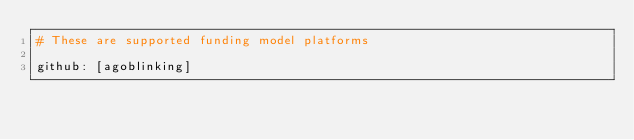<code> <loc_0><loc_0><loc_500><loc_500><_YAML_># These are supported funding model platforms

github: [agoblinking]

</code> 